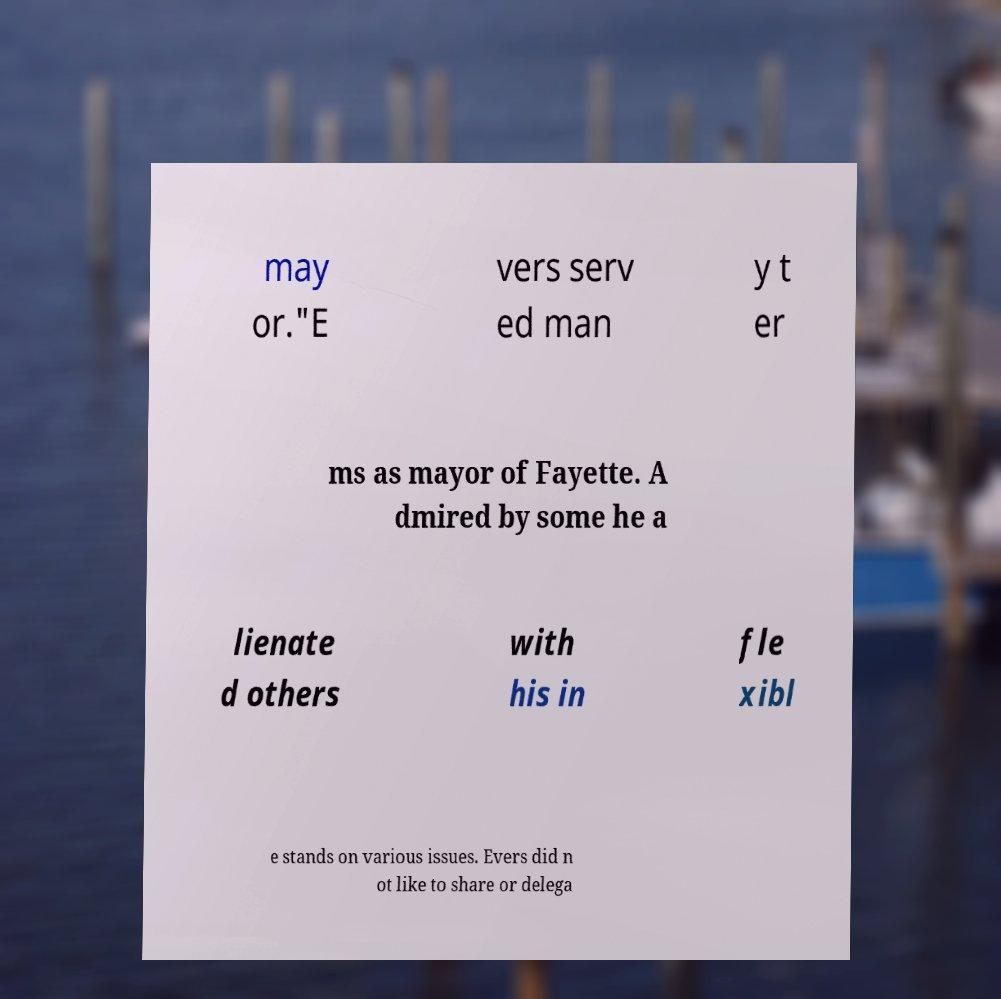There's text embedded in this image that I need extracted. Can you transcribe it verbatim? may or."E vers serv ed man y t er ms as mayor of Fayette. A dmired by some he a lienate d others with his in fle xibl e stands on various issues. Evers did n ot like to share or delega 